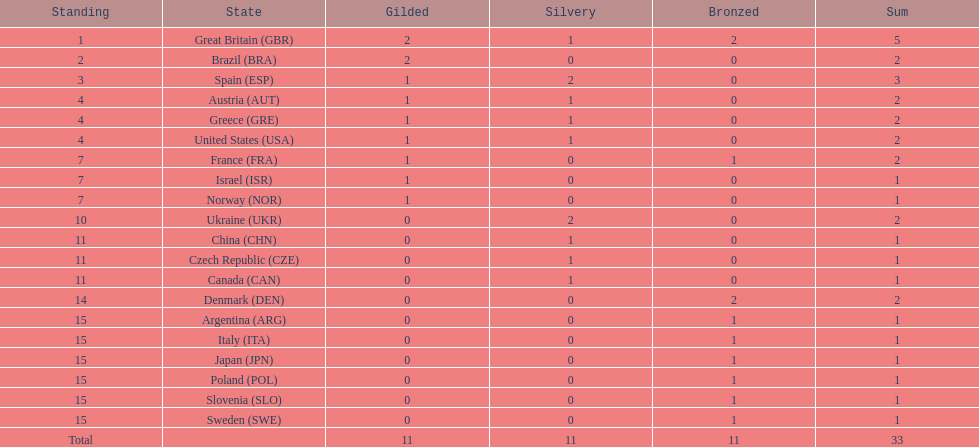In how many nations have athletes secured a minimum of one gold and one silver medal? 5. 